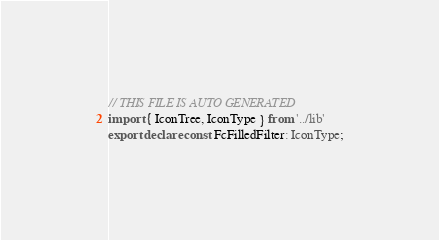Convert code to text. <code><loc_0><loc_0><loc_500><loc_500><_TypeScript_>// THIS FILE IS AUTO GENERATED
import { IconTree, IconType } from '../lib'
export declare const FcFilledFilter: IconType;
</code> 